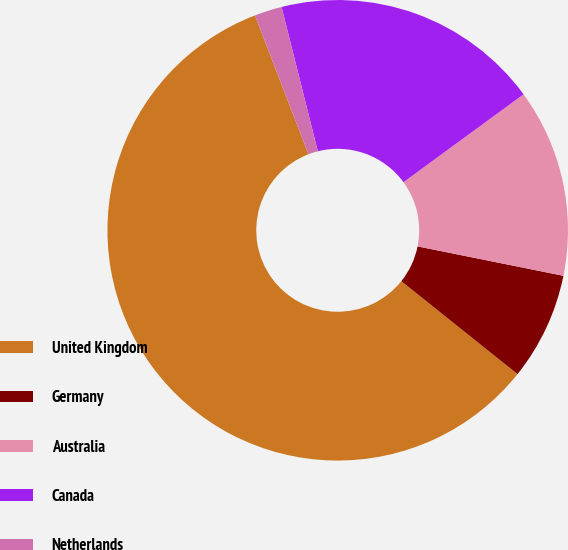Convert chart. <chart><loc_0><loc_0><loc_500><loc_500><pie_chart><fcel>United Kingdom<fcel>Germany<fcel>Australia<fcel>Canada<fcel>Netherlands<nl><fcel>58.41%<fcel>7.57%<fcel>13.22%<fcel>18.87%<fcel>1.93%<nl></chart> 